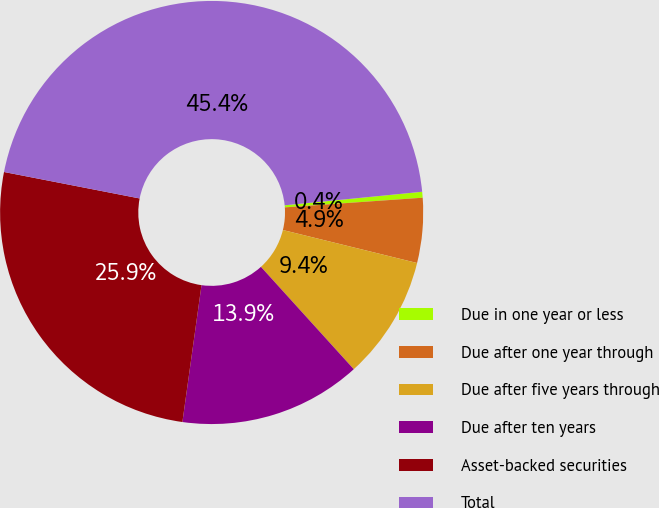Convert chart. <chart><loc_0><loc_0><loc_500><loc_500><pie_chart><fcel>Due in one year or less<fcel>Due after one year through<fcel>Due after five years through<fcel>Due after ten years<fcel>Asset-backed securities<fcel>Total<nl><fcel>0.45%<fcel>4.95%<fcel>9.44%<fcel>13.93%<fcel>25.86%<fcel>45.37%<nl></chart> 